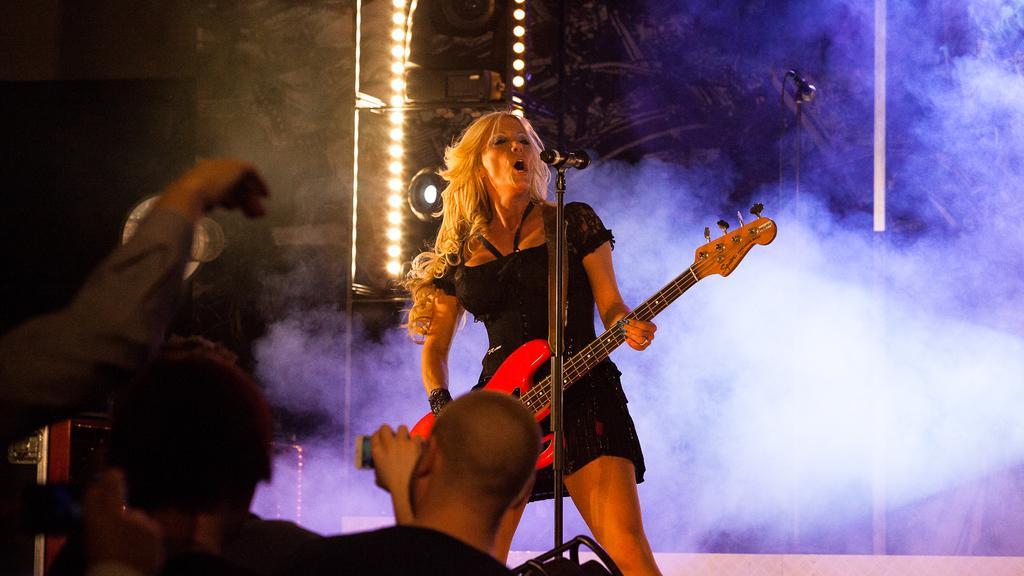Can you describe this image briefly? This person standing and holding guitar and singing. These are audience. There is a microphone with stand. On the background we can see lights,smoke. 